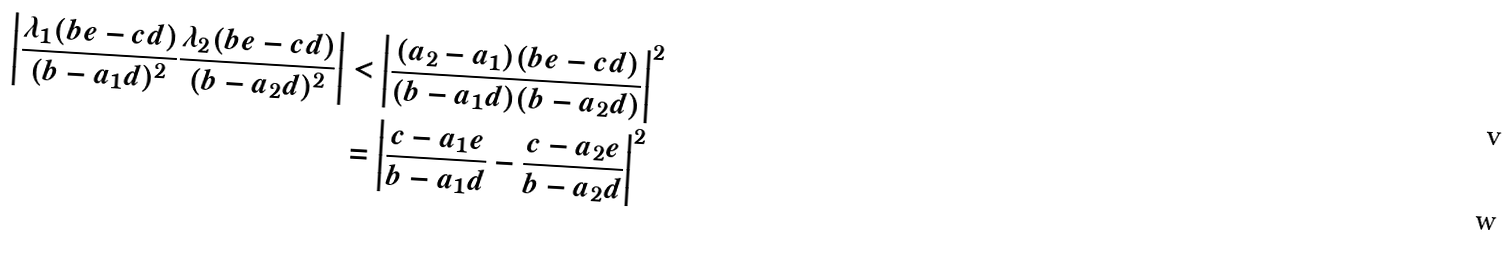Convert formula to latex. <formula><loc_0><loc_0><loc_500><loc_500>\left | \frac { \lambda _ { 1 } ( b e - c d ) } { ( b - a _ { 1 } d ) ^ { 2 } } \frac { \lambda _ { 2 } ( b e - c d ) } { ( b - a _ { 2 } d ) ^ { 2 } } \right | & < \left | \frac { ( a _ { 2 } - a _ { 1 } ) ( b e - c d ) } { ( b - a _ { 1 } d ) ( b - a _ { 2 } d ) } \right | ^ { 2 } \\ & = \left | \frac { c - a _ { 1 } e } { b - a _ { 1 } d } - \frac { c - a _ { 2 } e } { b - a _ { 2 } d } \right | ^ { 2 }</formula> 